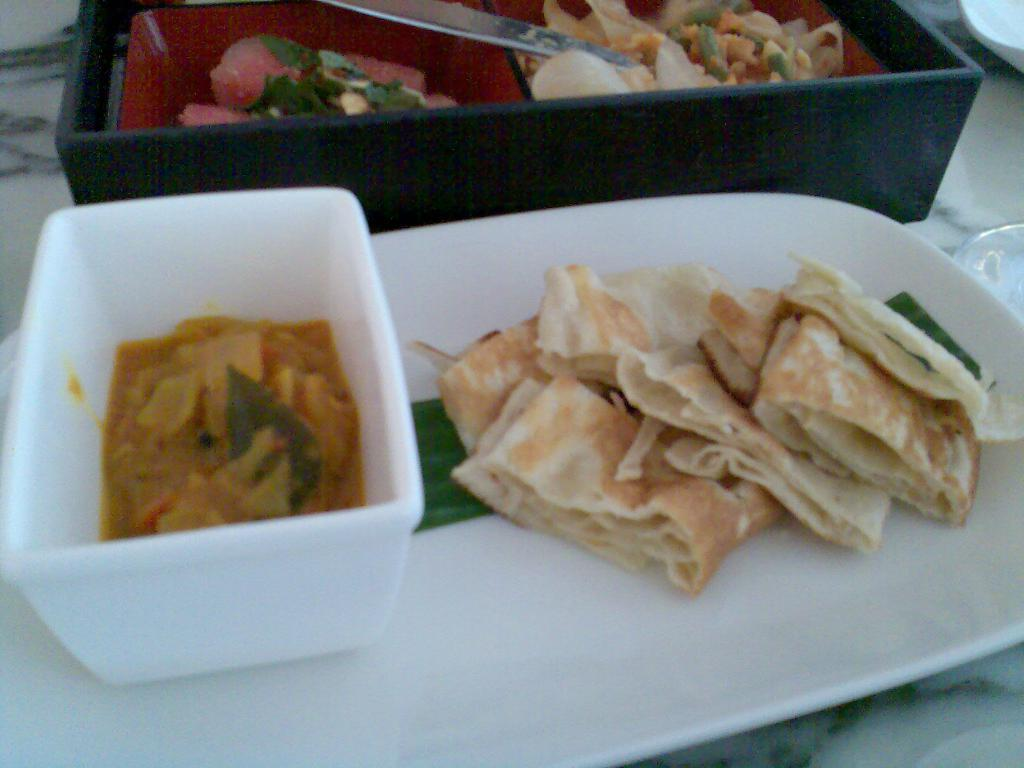What is present in the image that can be used for holding food? There is a bowl and a plate in the image that can be used for holding food. What else can be seen in the image that is related to eating? There is a box containing food items and a spoon in the image. Are there any other bowls visible in the image? Yes, there are additional bowls on the right side of the image. Can you describe the snails crawling on the shoes in the image? There are no snails or shoes present in the image. 